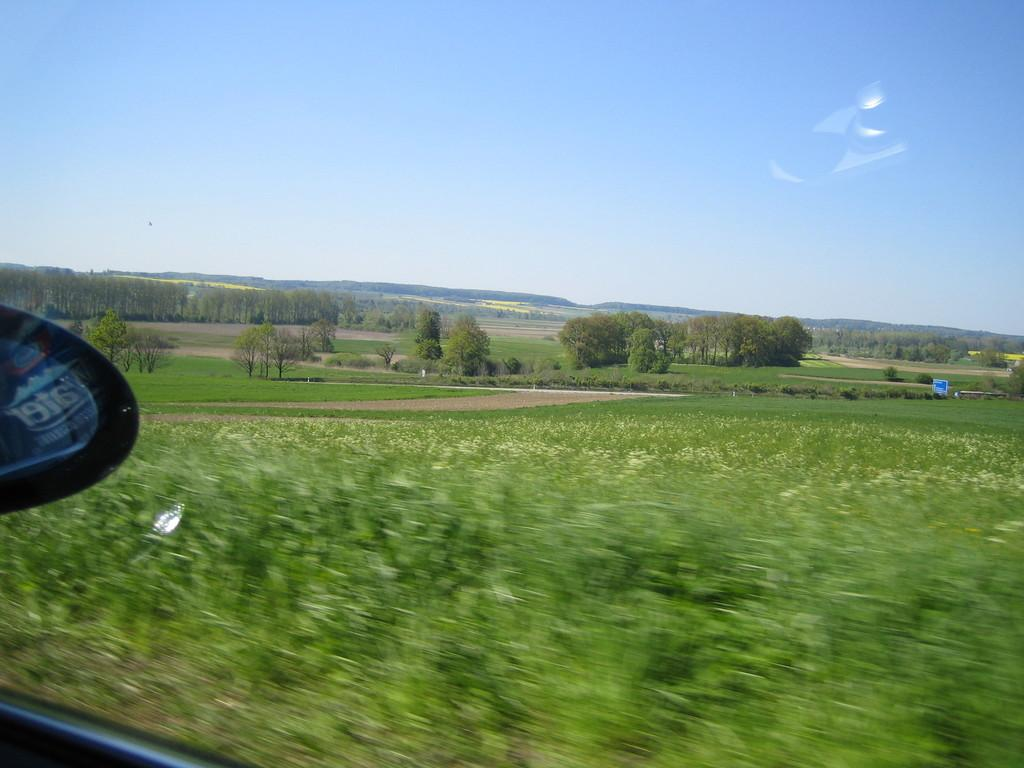What type of vehicle is shown in the image? The image depicts a vehicle, but the specific type is not mentioned in the facts. What feature of the vehicle is made of glass? The vehicle has a glass component, but the specific part is not mentioned in the facts. What can be seen outside the vehicle in the image? There are trees visible outside the vehicle in the image. What is visible at the top of the image? The sky is visible at the top of the image. What type of alley can be seen behind the vehicle in the image? There is no alley visible in the image; only trees are mentioned as being outside the vehicle. 